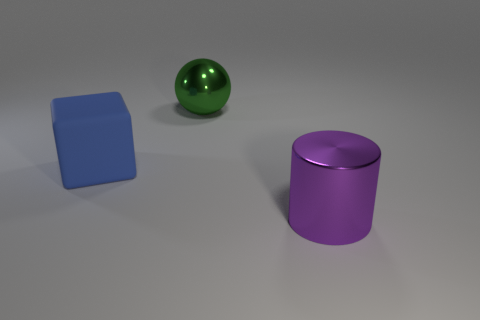How many objects are either green objects or large things behind the large purple shiny object? In the image, there is one green object, which is a sphere. Regarding large objects behind the large purple object, a cylinder, there are none visible. Therefore, the total count of objects that are either green or large things behind the large purple object is 1. 